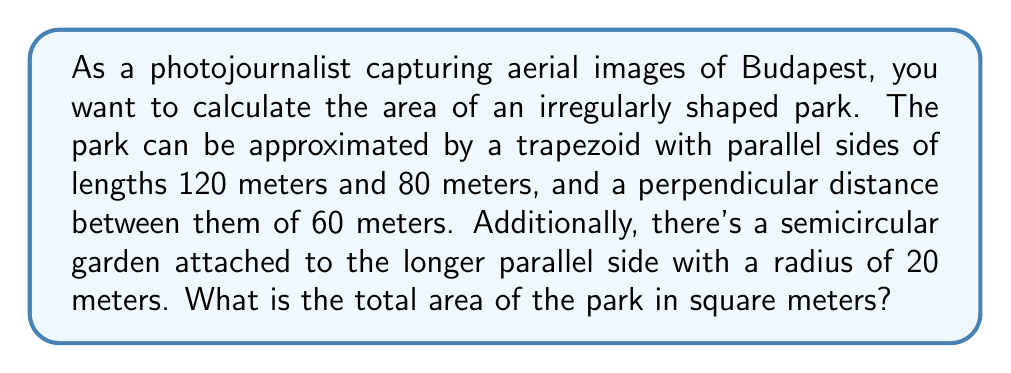Teach me how to tackle this problem. Let's approach this problem step by step:

1. Calculate the area of the trapezoid:
   The formula for the area of a trapezoid is:
   $$A_t = \frac{1}{2}(a+b)h$$
   where $a$ and $b$ are the parallel sides and $h$ is the height.

   $$A_t = \frac{1}{2}(120+80) \cdot 60 = \frac{1}{2} \cdot 200 \cdot 60 = 6000 \text{ m}^2$$

2. Calculate the area of the semicircle:
   The formula for the area of a circle is $\pi r^2$, so for a semicircle it's:
   $$A_s = \frac{1}{2}\pi r^2$$

   $$A_s = \frac{1}{2} \cdot \pi \cdot 20^2 = 200\pi \text{ m}^2$$

3. Sum the areas:
   Total Area = Area of trapezoid + Area of semicircle
   $$A_{total} = 6000 + 200\pi \text{ m}^2$$

4. Simplify:
   $$A_{total} = 6000 + 200\pi \approx 6628.32 \text{ m}^2$$

[asy]
import geometry;

size(200);

pair A = (0,0), B = (120,0), C = (100,60), D = (20,60);
path p = A--B--C--D--cycle;
draw(p);

pair E = (60,0);
path q = Arc(E,20,0,180);
draw(q);

label("120m", (60,-5), S);
label("80m", (60,65), N);
label("60m", (-5,30), W);
label("r=20m", (60,25), E);
[/asy]
Answer: $6000 + 200\pi \text{ m}^2$ or approximately $6628.32 \text{ m}^2$ 